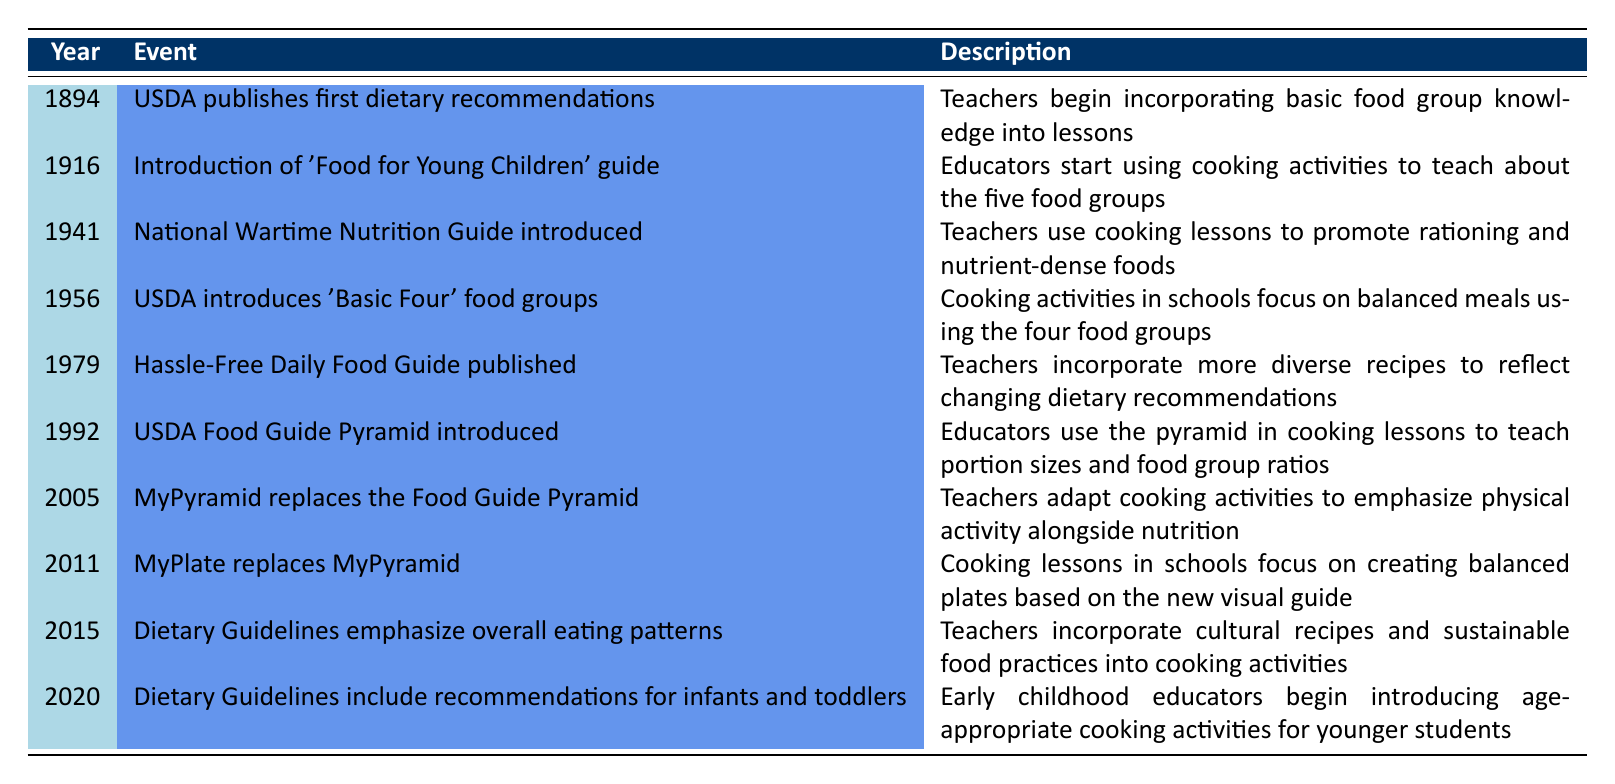What year did the USDA publish its first dietary recommendations? The timeline indicates that the USDA published its first dietary recommendations in 1894. We can refer directly to the row in the table that lists this event.
Answer: 1894 What cooking approach did educators start using in 1916? In 1916, the timeline shows that educators started using cooking activities to teach about the five food groups, as noted in the corresponding description for that year.
Answer: Cooking activities to teach about the five food groups What was introduced in 2011 that changed the focus of cooking lessons in schools? The timeline shows that in 2011, MyPlate replaced MyPyramid, which shifted cooking lessons to focus on creating balanced plates based on a new visual guide. This is directly mentioned in the description for that year.
Answer: MyPlate How many years passed between the introduction of the 'Basic Four' food groups and the 'Hassle-Free Daily Food Guide'? The 'Basic Four' food groups were introduced in 1956 and the 'Hassle-Free Daily Food Guide' in 1979. We can find the difference by subtracting 1956 from 1979, which equals 23 years.
Answer: 23 years Is it true that cooking lessons have always emphasized balanced meals according to the timeline? By examining the timeline, we see that the emphasis on balanced meals started with the introduction of 'Basic Four' food groups in 1956 and continued through different guidelines. However, prior to this, recommendations like those from USDA in 1894 focused more generally on food group knowledge instead of specific balanced meals. Thus, it is not always true.
Answer: No What trend can be observed in the progression of dietary guidelines from 1894 to 2020 in educational settings? From 1894 to 2020, the timeline indicates a gradual evolution from basic food group education to comprehensive dietary guidelines that include considerations for infants and toddlers as well as cultural recipes and sustainability. This shows an increasing sophistication and inclusivity in nutritional education.
Answer: Increasing complexity and inclusivity in nutritional education How many different dietary guideline frameworks were introduced between 1941 and 2015? The table lists several frameworks: the National Wartime Nutrition Guide (1941), the Basic Four (1956), the Hassle-Free Daily Food Guide (1979), the Food Guide Pyramid (1992), MyPyramid (2005), and MyPlate (2011). Summing these gives us six different frameworks introduced between 1941 and 2015.
Answer: 6 frameworks What year marks the introduction of age-appropriate cooking activities? The introduction of age-appropriate cooking activities for younger students occurred in 2020, as noted in the description for that year's entry in the timeline.
Answer: 2020 